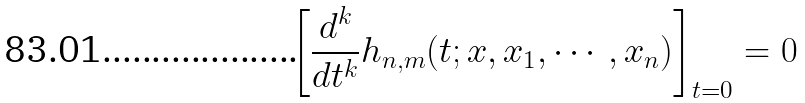Convert formula to latex. <formula><loc_0><loc_0><loc_500><loc_500>\left [ \frac { d ^ { k } } { d t ^ { k } } h _ { n , m } ( t ; x , x _ { 1 } , \cdots , x _ { n } ) \right ] _ { t = 0 } = 0</formula> 